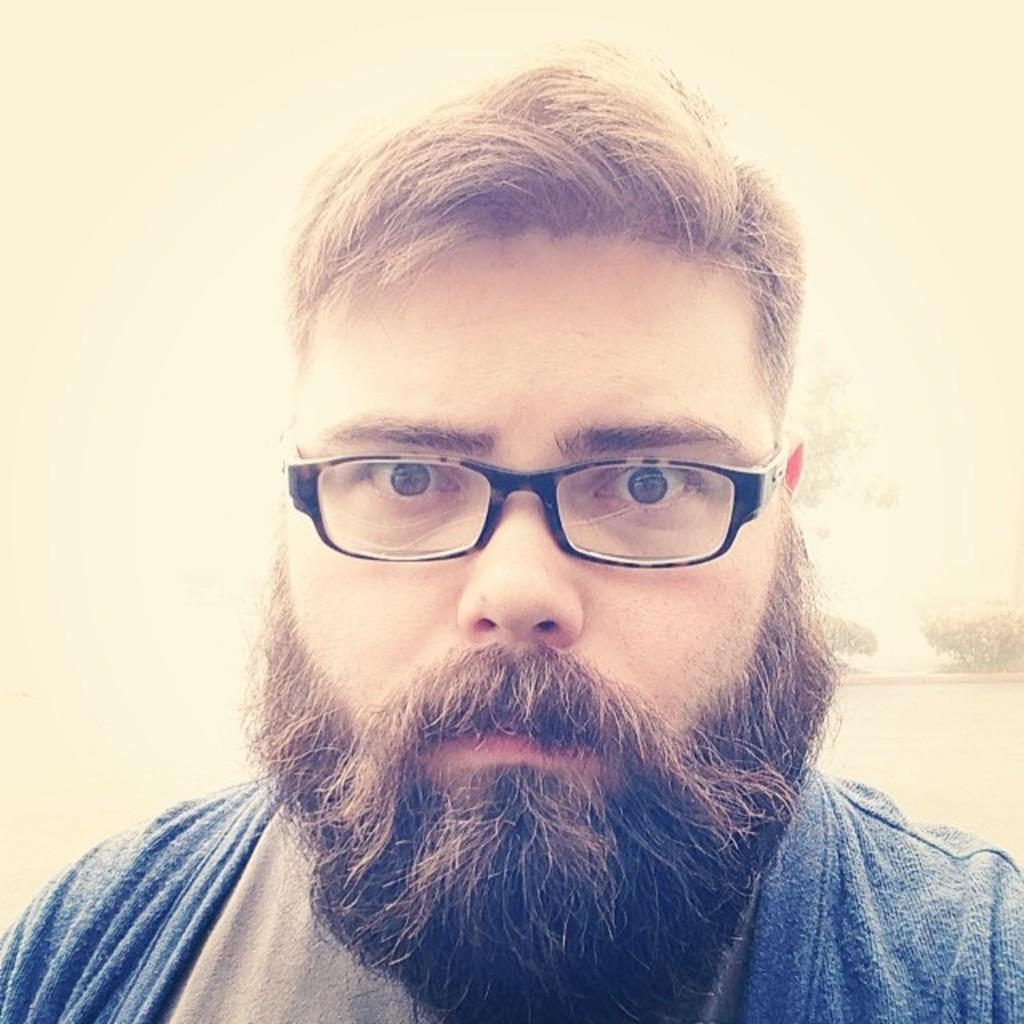What is the main subject of the image? There is a person in the image. Can you describe the person's appearance? The person is wearing spectacles. What type of road can be seen in the image? There is no road present in the image; it only features a person wearing spectacles. How many rabbits are visible in the image? There are no rabbits present in the image. 